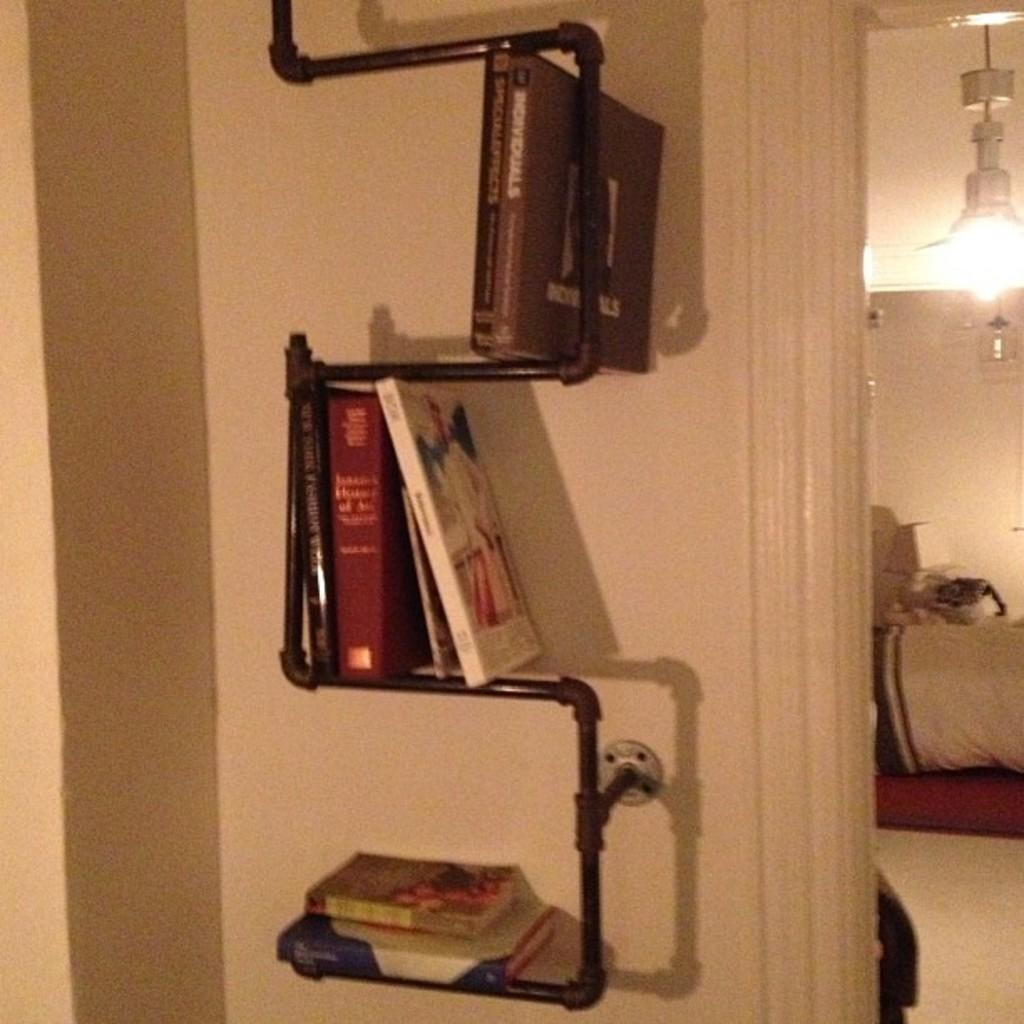What type of items can be seen in the image? There are books and a metallic object in the image. What can be seen in the background of the image? There is a wall visible in the image. Where are the objects located in the image? There are objects on the right side of the image. What is attached to the roof in the image? There is a light attached to the roof in the image. What type of leaf can be seen falling from the metallic object in the image? There is no leaf present in the image, and the metallic object is not depicted as having any leaves attached to it. 